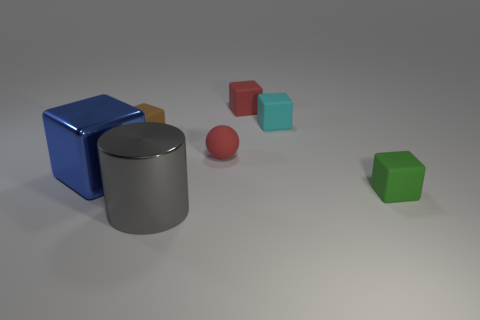If these shapes were part of a child's toy set, what sort of game or activity do you think they might be used for? If these shapes were part of a child's toy set, they could be used for an educational activity where children learn about geometry and colors. The shapes could be stacked or arranged to fit into specific outlines on a board, enhancing the child's spatial awareness, coordination, and understanding of three-dimensional objects. 